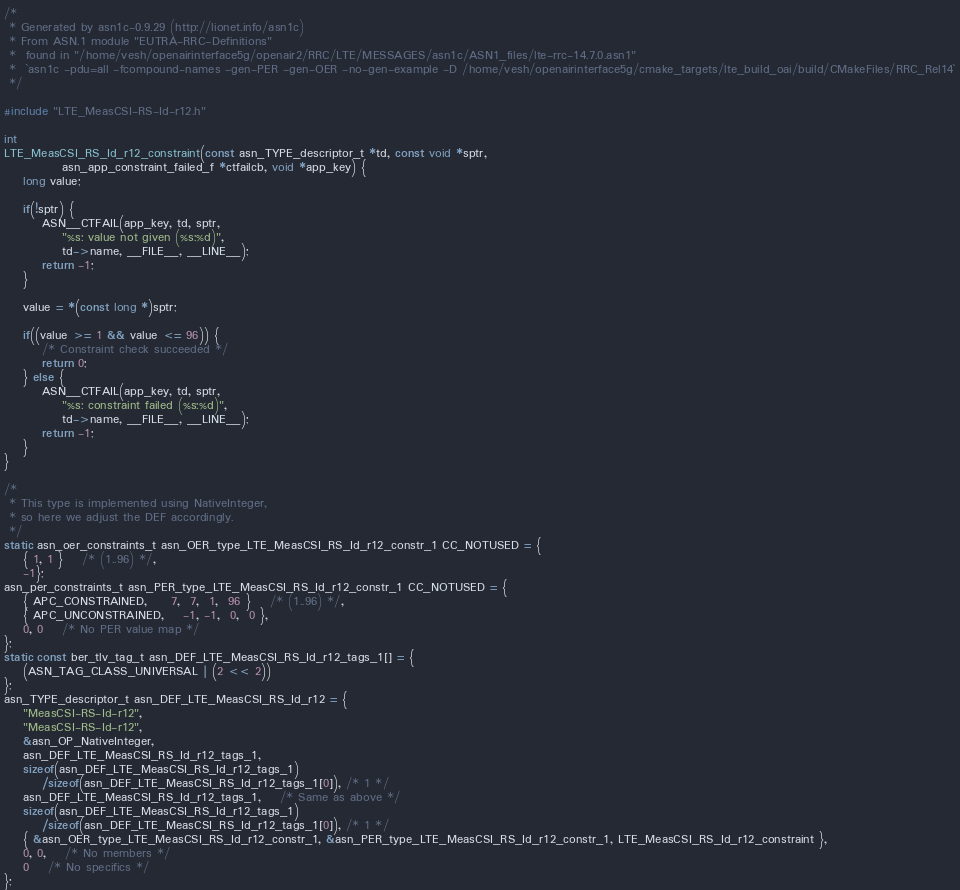Convert code to text. <code><loc_0><loc_0><loc_500><loc_500><_C_>/*
 * Generated by asn1c-0.9.29 (http://lionet.info/asn1c)
 * From ASN.1 module "EUTRA-RRC-Definitions"
 * 	found in "/home/vesh/openairinterface5g/openair2/RRC/LTE/MESSAGES/asn1c/ASN1_files/lte-rrc-14.7.0.asn1"
 * 	`asn1c -pdu=all -fcompound-names -gen-PER -gen-OER -no-gen-example -D /home/vesh/openairinterface5g/cmake_targets/lte_build_oai/build/CMakeFiles/RRC_Rel14`
 */

#include "LTE_MeasCSI-RS-Id-r12.h"

int
LTE_MeasCSI_RS_Id_r12_constraint(const asn_TYPE_descriptor_t *td, const void *sptr,
			asn_app_constraint_failed_f *ctfailcb, void *app_key) {
	long value;
	
	if(!sptr) {
		ASN__CTFAIL(app_key, td, sptr,
			"%s: value not given (%s:%d)",
			td->name, __FILE__, __LINE__);
		return -1;
	}
	
	value = *(const long *)sptr;
	
	if((value >= 1 && value <= 96)) {
		/* Constraint check succeeded */
		return 0;
	} else {
		ASN__CTFAIL(app_key, td, sptr,
			"%s: constraint failed (%s:%d)",
			td->name, __FILE__, __LINE__);
		return -1;
	}
}

/*
 * This type is implemented using NativeInteger,
 * so here we adjust the DEF accordingly.
 */
static asn_oer_constraints_t asn_OER_type_LTE_MeasCSI_RS_Id_r12_constr_1 CC_NOTUSED = {
	{ 1, 1 }	/* (1..96) */,
	-1};
asn_per_constraints_t asn_PER_type_LTE_MeasCSI_RS_Id_r12_constr_1 CC_NOTUSED = {
	{ APC_CONSTRAINED,	 7,  7,  1,  96 }	/* (1..96) */,
	{ APC_UNCONSTRAINED,	-1, -1,  0,  0 },
	0, 0	/* No PER value map */
};
static const ber_tlv_tag_t asn_DEF_LTE_MeasCSI_RS_Id_r12_tags_1[] = {
	(ASN_TAG_CLASS_UNIVERSAL | (2 << 2))
};
asn_TYPE_descriptor_t asn_DEF_LTE_MeasCSI_RS_Id_r12 = {
	"MeasCSI-RS-Id-r12",
	"MeasCSI-RS-Id-r12",
	&asn_OP_NativeInteger,
	asn_DEF_LTE_MeasCSI_RS_Id_r12_tags_1,
	sizeof(asn_DEF_LTE_MeasCSI_RS_Id_r12_tags_1)
		/sizeof(asn_DEF_LTE_MeasCSI_RS_Id_r12_tags_1[0]), /* 1 */
	asn_DEF_LTE_MeasCSI_RS_Id_r12_tags_1,	/* Same as above */
	sizeof(asn_DEF_LTE_MeasCSI_RS_Id_r12_tags_1)
		/sizeof(asn_DEF_LTE_MeasCSI_RS_Id_r12_tags_1[0]), /* 1 */
	{ &asn_OER_type_LTE_MeasCSI_RS_Id_r12_constr_1, &asn_PER_type_LTE_MeasCSI_RS_Id_r12_constr_1, LTE_MeasCSI_RS_Id_r12_constraint },
	0, 0,	/* No members */
	0	/* No specifics */
};

</code> 